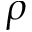Convert formula to latex. <formula><loc_0><loc_0><loc_500><loc_500>\rho</formula> 